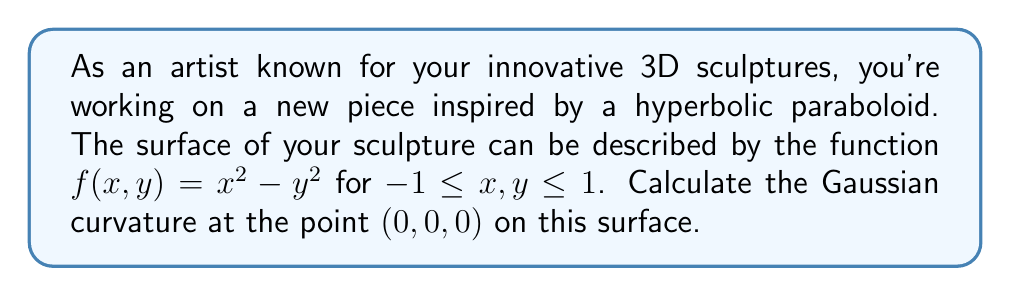Can you answer this question? To calculate the Gaussian curvature of the surface at the point (0,0,0), we'll follow these steps:

1) First, we need to calculate the partial derivatives of $f(x,y)$:

   $f_x = \frac{\partial f}{\partial x} = 2x$
   $f_y = \frac{\partial f}{\partial y} = -2y$
   $f_{xx} = \frac{\partial^2 f}{\partial x^2} = 2$
   $f_{yy} = \frac{\partial^2 f}{\partial y^2} = -2$
   $f_{xy} = f_{yx} = \frac{\partial^2 f}{\partial x \partial y} = 0$

2) Now, we need to calculate the coefficients of the first fundamental form:

   $E = 1 + f_x^2 = 1 + 4x^2$
   $F = f_x f_y = -4xy$
   $G = 1 + f_y^2 = 1 + 4y^2$

3) Next, we calculate the coefficients of the second fundamental form:

   $L = \frac{f_{xx}}{\sqrt{1 + f_x^2 + f_y^2}} = \frac{2}{\sqrt{1 + 4x^2 + 4y^2}}$
   $M = \frac{f_{xy}}{\sqrt{1 + f_x^2 + f_y^2}} = 0$
   $N = \frac{f_{yy}}{\sqrt{1 + f_x^2 + f_y^2}} = \frac{-2}{\sqrt{1 + 4x^2 + 4y^2}}$

4) The Gaussian curvature is given by:

   $K = \frac{LN - M^2}{EG - F^2}$

5) At the point (0,0,0), we have:

   $E = 1, F = 0, G = 1$
   $L = 2, M = 0, N = -2$

6) Substituting these values into the formula for Gaussian curvature:

   $K = \frac{(2)(-2) - 0^2}{(1)(1) - 0^2} = \frac{-4}{1} = -4$

Therefore, the Gaussian curvature at the point (0,0,0) is -4.
Answer: $K = -4$ 